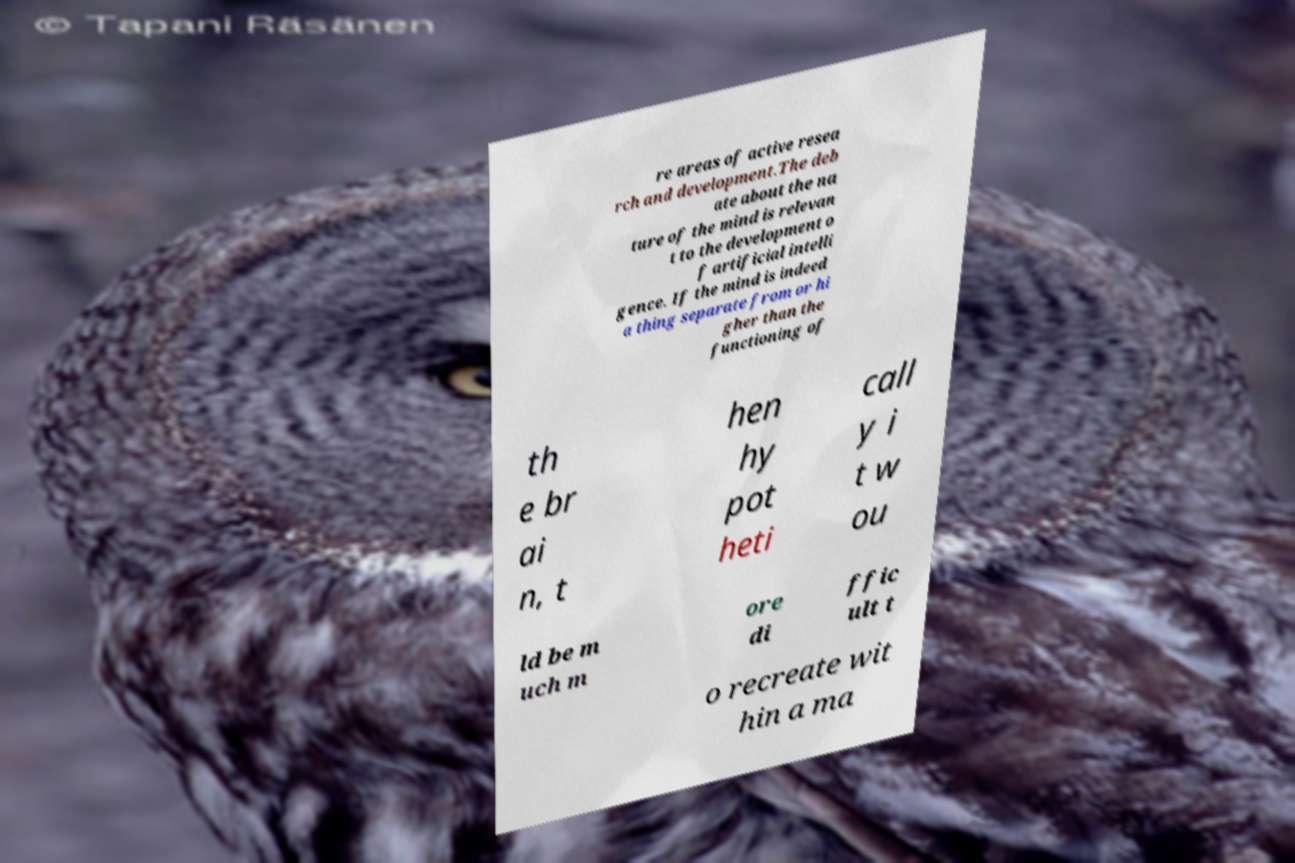Can you read and provide the text displayed in the image?This photo seems to have some interesting text. Can you extract and type it out for me? re areas of active resea rch and development.The deb ate about the na ture of the mind is relevan t to the development o f artificial intelli gence. If the mind is indeed a thing separate from or hi gher than the functioning of th e br ai n, t hen hy pot heti call y i t w ou ld be m uch m ore di ffic ult t o recreate wit hin a ma 